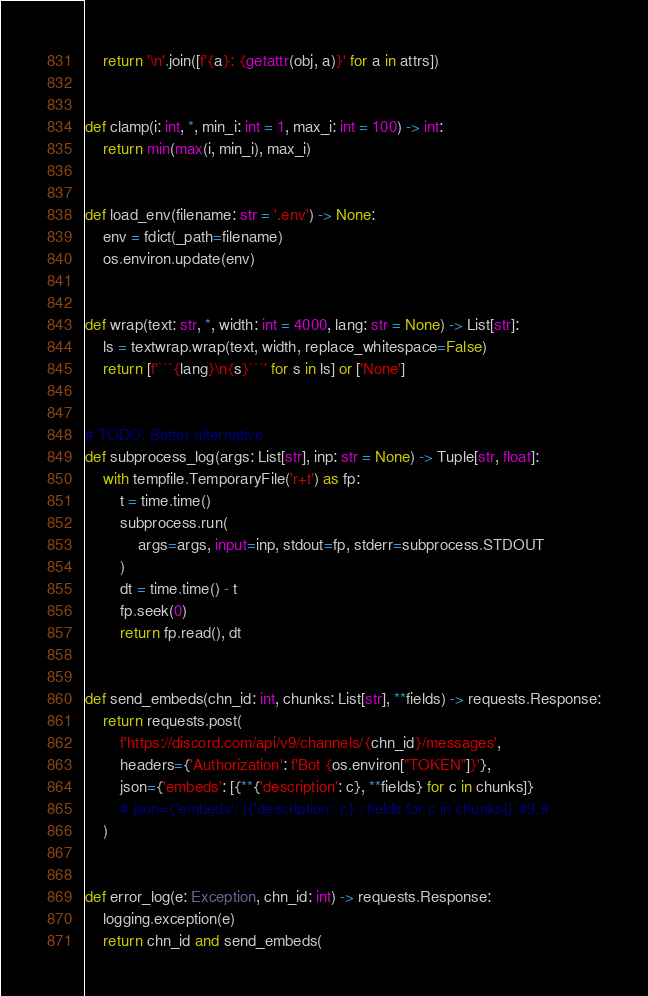Convert code to text. <code><loc_0><loc_0><loc_500><loc_500><_Python_>    return '\n'.join([f'{a}: {getattr(obj, a)}' for a in attrs])


def clamp(i: int, *, min_i: int = 1, max_i: int = 100) -> int:
    return min(max(i, min_i), max_i)


def load_env(filename: str = '.env') -> None:
    env = fdict(_path=filename)
    os.environ.update(env)


def wrap(text: str, *, width: int = 4000, lang: str = None) -> List[str]:
    ls = textwrap.wrap(text, width, replace_whitespace=False)
    return [f'```{lang}\n{s}```' for s in ls] or ['None']


# TODO: Better alternative
def subprocess_log(args: List[str], inp: str = None) -> Tuple[str, float]:
    with tempfile.TemporaryFile('r+t') as fp:
        t = time.time()
        subprocess.run(
            args=args, input=inp, stdout=fp, stderr=subprocess.STDOUT
        )
        dt = time.time() - t
        fp.seek(0)
        return fp.read(), dt


def send_embeds(chn_id: int, chunks: List[str], **fields) -> requests.Response:
    return requests.post(
        f'https://discord.com/api/v9/channels/{chn_id}/messages',
        headers={'Authorization': f'Bot {os.environ["TOKEN"]}'},
        json={'embeds': [{**{'description': c}, **fields} for c in chunks]}
        # json={'embeds': [{'description': c} | fields for c in chunks]} #3.9
    )


def error_log(e: Exception, chn_id: int) -> requests.Response:
    logging.exception(e)
    return chn_id and send_embeds(</code> 